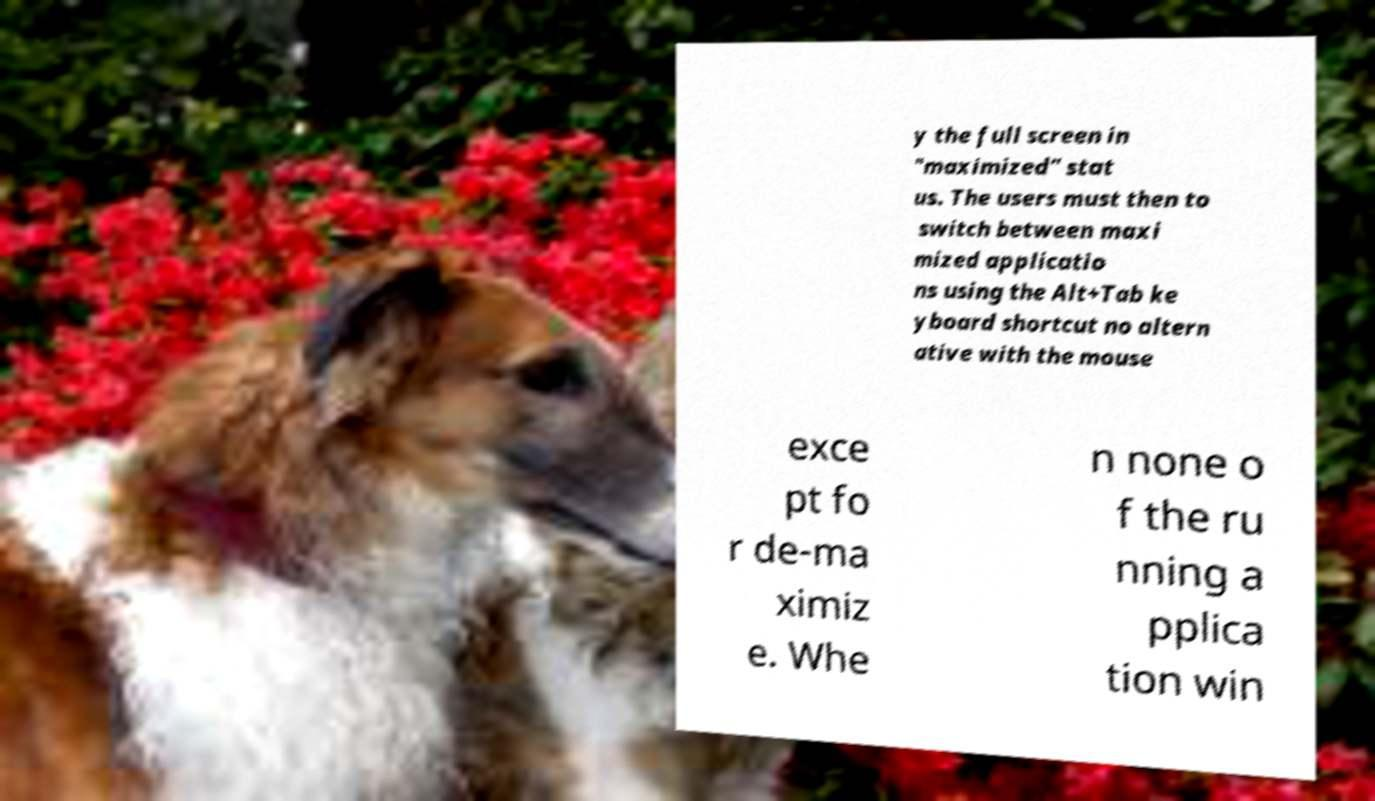Can you accurately transcribe the text from the provided image for me? y the full screen in "maximized" stat us. The users must then to switch between maxi mized applicatio ns using the Alt+Tab ke yboard shortcut no altern ative with the mouse exce pt fo r de-ma ximiz e. Whe n none o f the ru nning a pplica tion win 